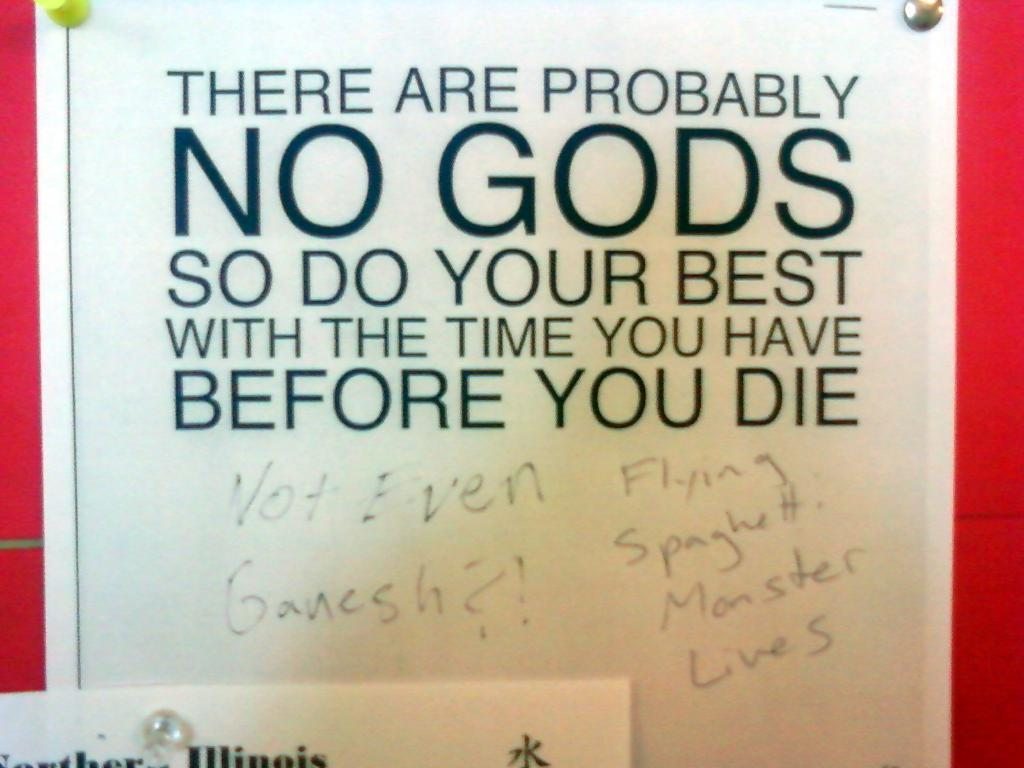<image>
Summarize the visual content of the image. A paper on a bullentin board that reads "There are probably No Gods so do your best with the time you have before you die" 